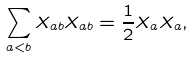<formula> <loc_0><loc_0><loc_500><loc_500>\sum _ { a < b } X _ { a b } X _ { a b } = \frac { 1 } { 2 } X _ { a } X _ { a } ,</formula> 